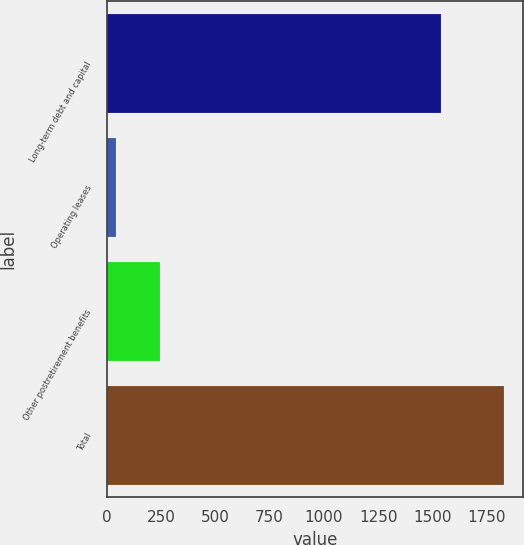Convert chart to OTSL. <chart><loc_0><loc_0><loc_500><loc_500><bar_chart><fcel>Long-term debt and capital<fcel>Operating leases<fcel>Other postretirement benefits<fcel>Total<nl><fcel>1540<fcel>43<fcel>244<fcel>1827<nl></chart> 